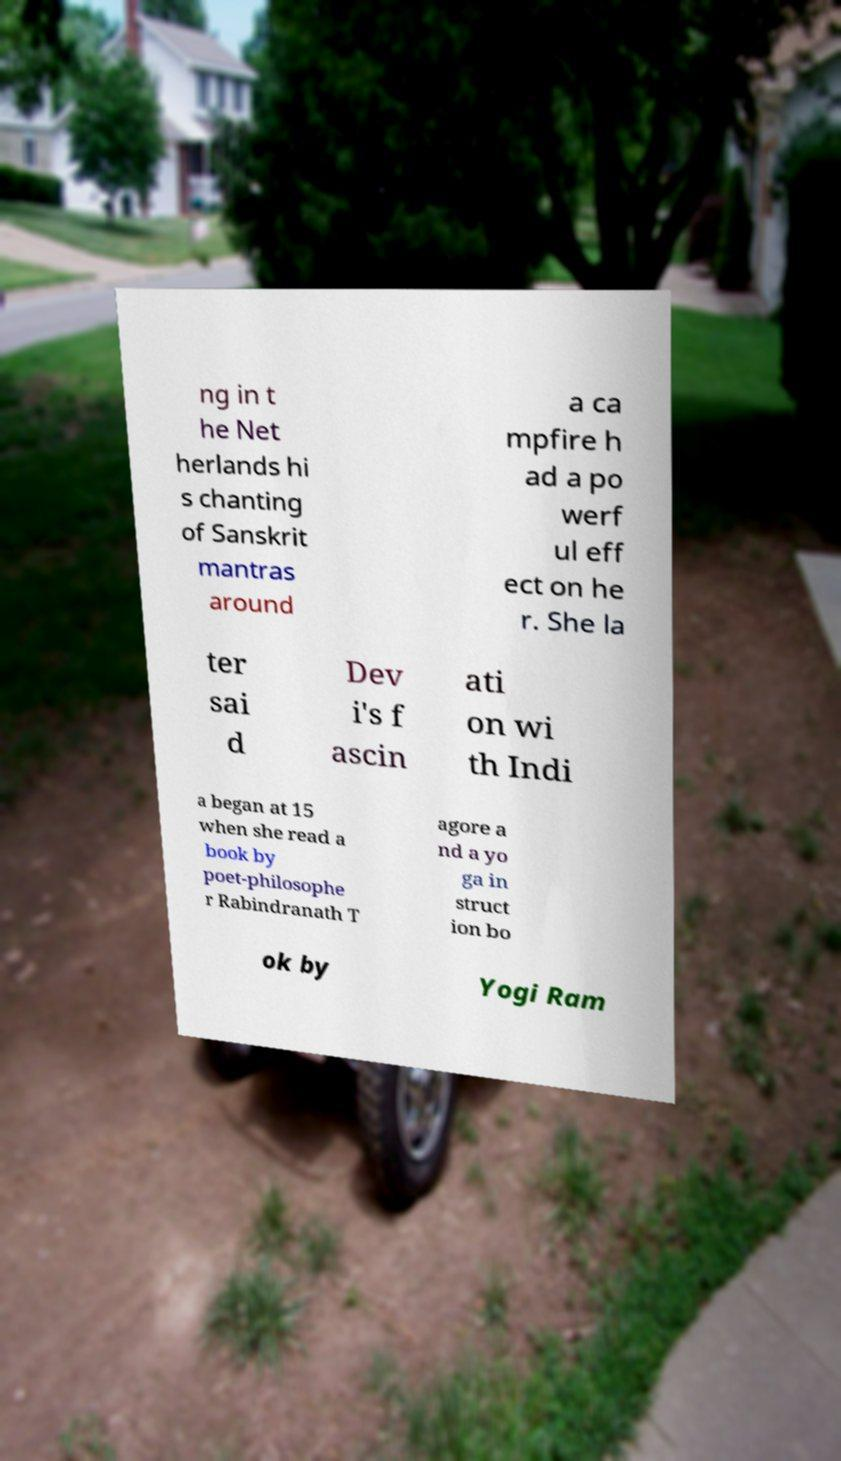Please identify and transcribe the text found in this image. ng in t he Net herlands hi s chanting of Sanskrit mantras around a ca mpfire h ad a po werf ul eff ect on he r. She la ter sai d Dev i's f ascin ati on wi th Indi a began at 15 when she read a book by poet-philosophe r Rabindranath T agore a nd a yo ga in struct ion bo ok by Yogi Ram 